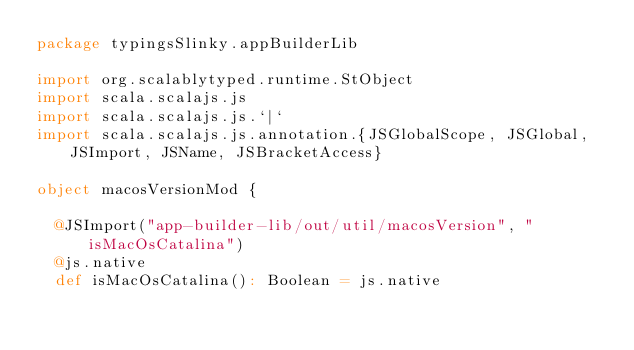Convert code to text. <code><loc_0><loc_0><loc_500><loc_500><_Scala_>package typingsSlinky.appBuilderLib

import org.scalablytyped.runtime.StObject
import scala.scalajs.js
import scala.scalajs.js.`|`
import scala.scalajs.js.annotation.{JSGlobalScope, JSGlobal, JSImport, JSName, JSBracketAccess}

object macosVersionMod {
  
  @JSImport("app-builder-lib/out/util/macosVersion", "isMacOsCatalina")
  @js.native
  def isMacOsCatalina(): Boolean = js.native
  </code> 